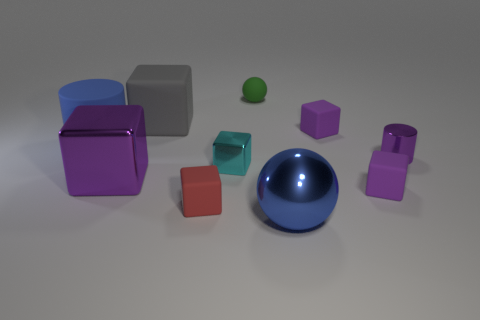What color is the metal thing that is both behind the large blue ball and right of the small green thing? The object you're inquiring about appears to be a large, magenta-colored cube situated behind the large blue sphere and to the right of the small green sphere. 